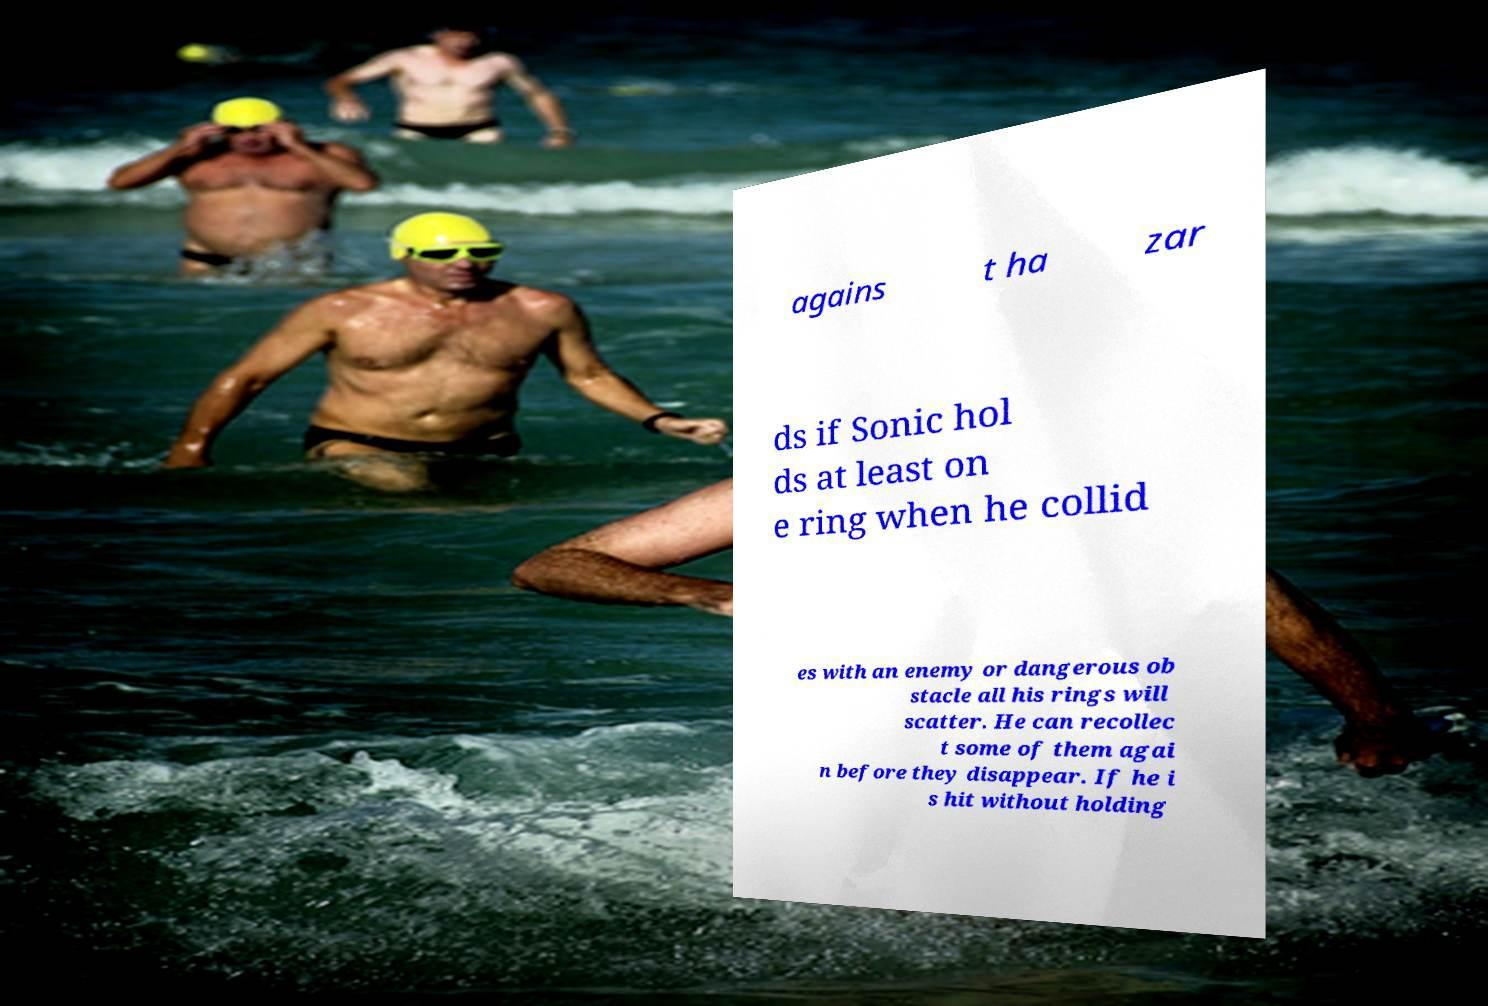Can you read and provide the text displayed in the image?This photo seems to have some interesting text. Can you extract and type it out for me? agains t ha zar ds if Sonic hol ds at least on e ring when he collid es with an enemy or dangerous ob stacle all his rings will scatter. He can recollec t some of them agai n before they disappear. If he i s hit without holding 